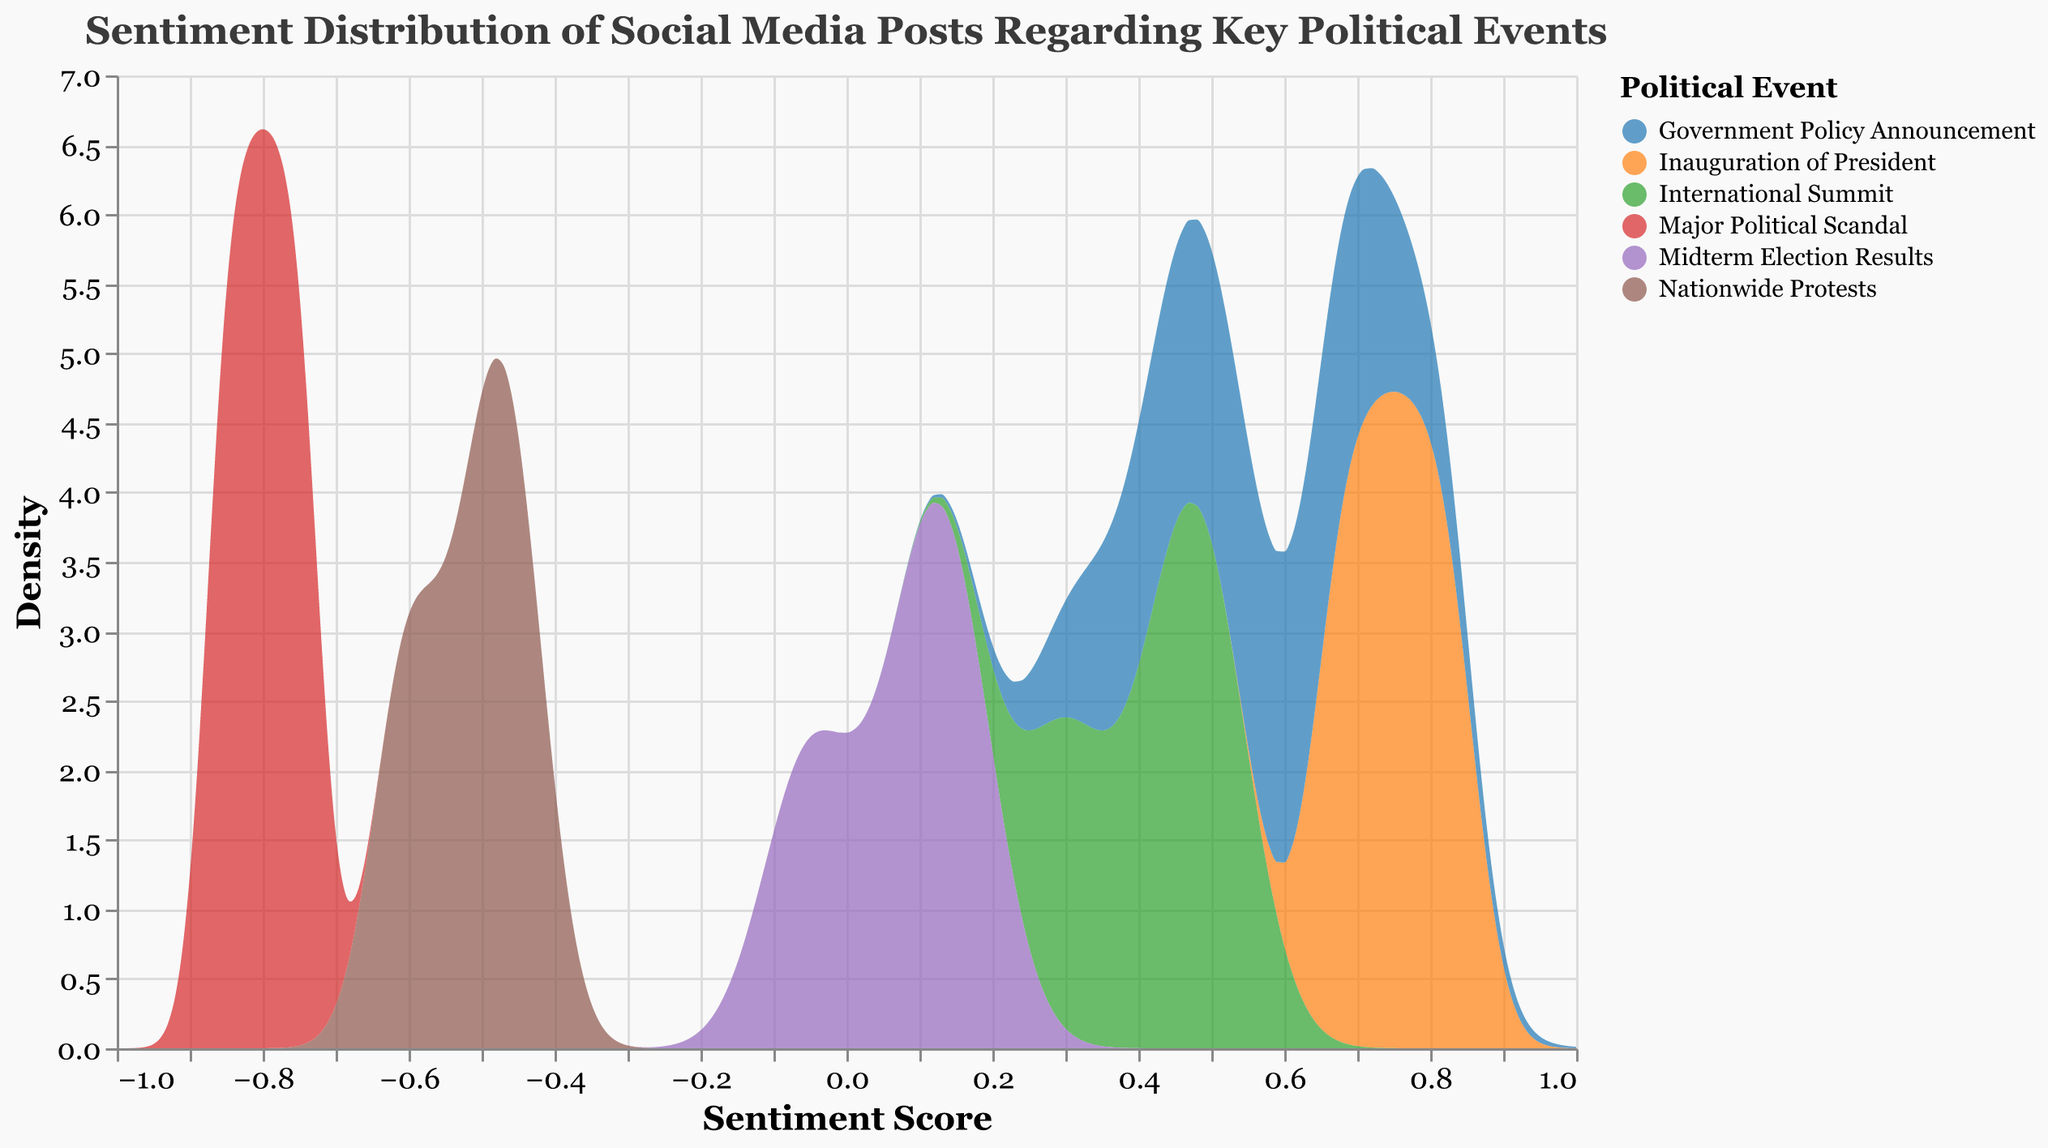How many political events are depicted in the plot? The title and the color legend indicate the distinct political events. If you count each unique political event category in the legend, you will find there are 6 different ones.
Answer: 6 Which political event has the most extreme negative sentiment score in the density plot? In the density plot, the most negative sentiment score appears furthest to the left on the x-axis. The event with the lowest extreme is "Major Political Scandal" with sentiment scores reaching close to -1.
Answer: Major Political Scandal What is the title of the plot? The title is mentioned at the top of the plot. It reads "Sentiment Distribution of Social Media Posts Regarding Key Political Events".
Answer: Sentiment Distribution of Social Media Posts Regarding Key Political Events Between "Government Policy Announcement" and "Nationwide Protests", which has a wider range of sentiment scores? To find the range, observe the spread of each event's area on the x-axis. "Government Policy Announcement" spans sentiment scores from about 0.35 to 0.75, while "Nationwide Protests" spans from around -0.65 to -0.40. Comparing these ranges, "Nationwide Protests" has a wider range.
Answer: Nationwide Protests Among all the political events, which appears to have the smallest density peak and for what sentiment score? Looking carefully at each density peak, "Midterm Election Results" has the lowest peak density. This is because the peak for this event does not rise as high on the y-axis as the others. The peak is around a sentiment score of 0.1.
Answer: Midterm Election Results, around 0.1 What sentiment score appears most frequently for the "Inauguration of President" event? The highest point of the density curve for "Inauguration of President" indicates the most frequent sentiment score. This peak occurs at around 0.75.
Answer: 0.75 Compare the average sentiment scores for "International Summit" and "Major Political Scandal". Which has a higher average sentiment score? Calculate the average sentiment for each event by summing their sentiment scores and dividing by the number of scores. For "International Summit" (0.30+0.45+0.50)/3 = 0.42. For "Major Political Scandal" (-0.80-0.85-0.75)/3 = -0.80. The average for "International Summit" is higher.
Answer: International Summit Which political event has the greatest density at a sentiment score of 0.5? Identify the curves that intersect at 0.5 on the x-axis, then see which one has the highest density value on the y-axis at this x value. "International Summit" has the greatest density at the sentiment score of 0.5.
Answer: International Summit 